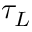<formula> <loc_0><loc_0><loc_500><loc_500>\tau _ { L }</formula> 